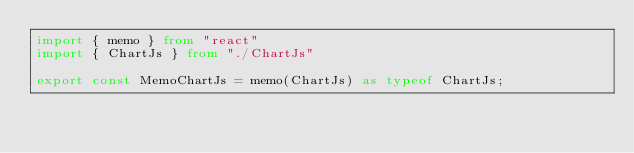<code> <loc_0><loc_0><loc_500><loc_500><_TypeScript_>import { memo } from "react"
import { ChartJs } from "./ChartJs"

export const MemoChartJs = memo(ChartJs) as typeof ChartJs;
</code> 